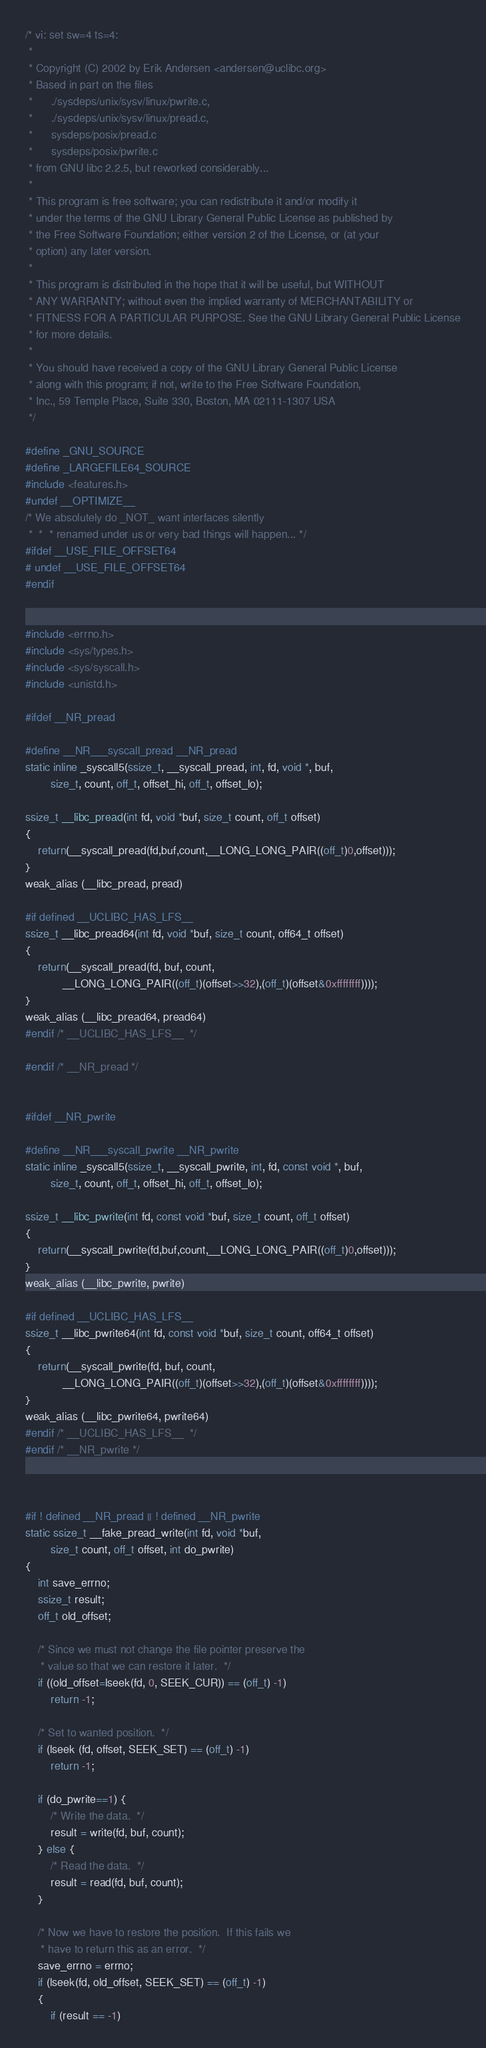Convert code to text. <code><loc_0><loc_0><loc_500><loc_500><_C_>/* vi: set sw=4 ts=4:
 *
 * Copyright (C) 2002 by Erik Andersen <andersen@uclibc.org>
 * Based in part on the files
 *		./sysdeps/unix/sysv/linux/pwrite.c,
 *		./sysdeps/unix/sysv/linux/pread.c, 
 *		sysdeps/posix/pread.c
 *		sysdeps/posix/pwrite.c
 * from GNU libc 2.2.5, but reworked considerably...
 *
 * This program is free software; you can redistribute it and/or modify it
 * under the terms of the GNU Library General Public License as published by
 * the Free Software Foundation; either version 2 of the License, or (at your
 * option) any later version.
 *
 * This program is distributed in the hope that it will be useful, but WITHOUT
 * ANY WARRANTY; without even the implied warranty of MERCHANTABILITY or
 * FITNESS FOR A PARTICULAR PURPOSE. See the GNU Library General Public License
 * for more details.
 *
 * You should have received a copy of the GNU Library General Public License
 * along with this program; if not, write to the Free Software Foundation,
 * Inc., 59 Temple Place, Suite 330, Boston, MA 02111-1307 USA
 */

#define _GNU_SOURCE
#define _LARGEFILE64_SOURCE
#include <features.h>
#undef __OPTIMIZE__
/* We absolutely do _NOT_ want interfaces silently
 *  *  * renamed under us or very bad things will happen... */
#ifdef __USE_FILE_OFFSET64
# undef __USE_FILE_OFFSET64
#endif


#include <errno.h>
#include <sys/types.h>
#include <sys/syscall.h>
#include <unistd.h>

#ifdef __NR_pread

#define __NR___syscall_pread __NR_pread 
static inline _syscall5(ssize_t, __syscall_pread, int, fd, void *, buf, 
		size_t, count, off_t, offset_hi, off_t, offset_lo);

ssize_t __libc_pread(int fd, void *buf, size_t count, off_t offset)
{ 
	return(__syscall_pread(fd,buf,count,__LONG_LONG_PAIR((off_t)0,offset)));
}
weak_alias (__libc_pread, pread)

#if defined __UCLIBC_HAS_LFS__ 
ssize_t __libc_pread64(int fd, void *buf, size_t count, off64_t offset)
{ 
	return(__syscall_pread(fd, buf, count,
			__LONG_LONG_PAIR((off_t)(offset>>32),(off_t)(offset&0xffffffff))));
}
weak_alias (__libc_pread64, pread64)
#endif /* __UCLIBC_HAS_LFS__  */

#endif /* __NR_pread */


#ifdef __NR_pwrite

#define __NR___syscall_pwrite __NR_pwrite 
static inline _syscall5(ssize_t, __syscall_pwrite, int, fd, const void *, buf, 
		size_t, count, off_t, offset_hi, off_t, offset_lo);

ssize_t __libc_pwrite(int fd, const void *buf, size_t count, off_t offset)
{ 
	return(__syscall_pwrite(fd,buf,count,__LONG_LONG_PAIR((off_t)0,offset)));
}
weak_alias (__libc_pwrite, pwrite)

#if defined __UCLIBC_HAS_LFS__ 
ssize_t __libc_pwrite64(int fd, const void *buf, size_t count, off64_t offset)
{ 
	return(__syscall_pwrite(fd, buf, count,
			__LONG_LONG_PAIR((off_t)(offset>>32),(off_t)(offset&0xffffffff))));
}
weak_alias (__libc_pwrite64, pwrite64)
#endif /* __UCLIBC_HAS_LFS__  */
#endif /* __NR_pwrite */



#if ! defined __NR_pread || ! defined __NR_pwrite
static ssize_t __fake_pread_write(int fd, void *buf, 
		size_t count, off_t offset, int do_pwrite)
{
	int save_errno;
	ssize_t result;
	off_t old_offset;

	/* Since we must not change the file pointer preserve the 
	 * value so that we can restore it later.  */
	if ((old_offset=lseek(fd, 0, SEEK_CUR)) == (off_t) -1)
		return -1;

	/* Set to wanted position.  */
	if (lseek (fd, offset, SEEK_SET) == (off_t) -1)
		return -1;

	if (do_pwrite==1) {
		/* Write the data.  */
		result = write(fd, buf, count);
	} else {
		/* Read the data.  */
		result = read(fd, buf, count);
	}

	/* Now we have to restore the position.  If this fails we 
	 * have to return this as an error.  */
	save_errno = errno;
	if (lseek(fd, old_offset, SEEK_SET) == (off_t) -1)
	{
		if (result == -1)</code> 